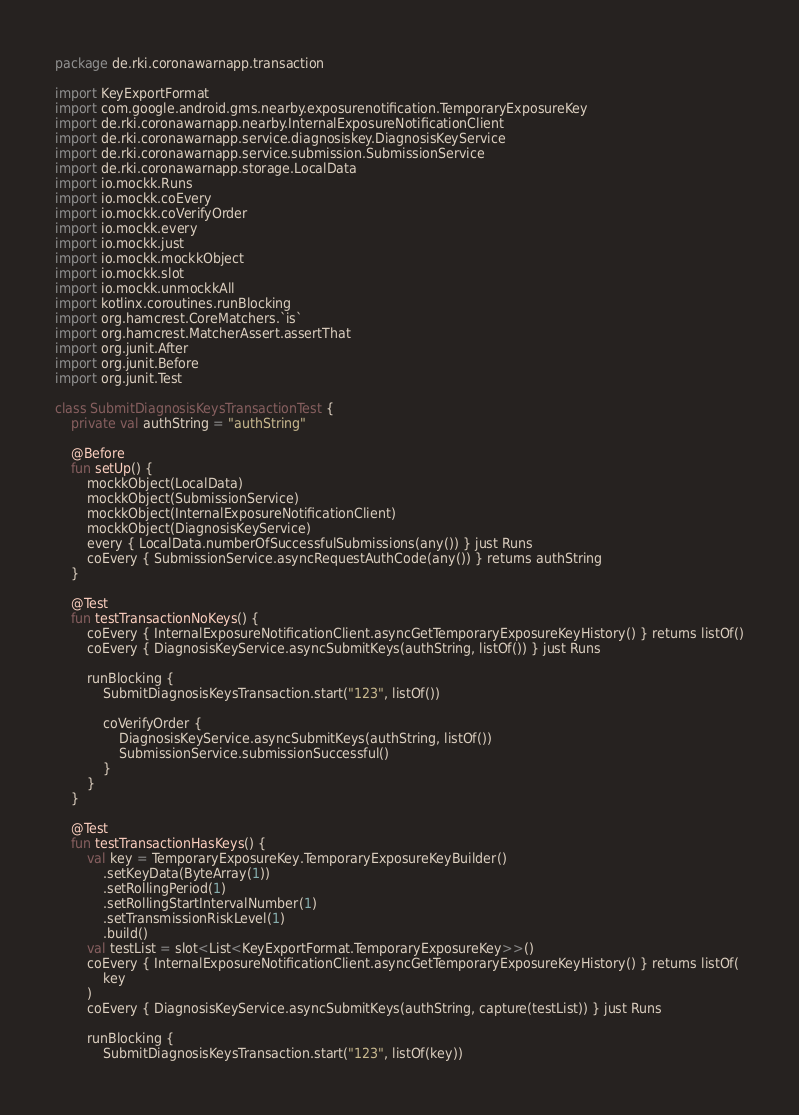Convert code to text. <code><loc_0><loc_0><loc_500><loc_500><_Kotlin_>package de.rki.coronawarnapp.transaction

import KeyExportFormat
import com.google.android.gms.nearby.exposurenotification.TemporaryExposureKey
import de.rki.coronawarnapp.nearby.InternalExposureNotificationClient
import de.rki.coronawarnapp.service.diagnosiskey.DiagnosisKeyService
import de.rki.coronawarnapp.service.submission.SubmissionService
import de.rki.coronawarnapp.storage.LocalData
import io.mockk.Runs
import io.mockk.coEvery
import io.mockk.coVerifyOrder
import io.mockk.every
import io.mockk.just
import io.mockk.mockkObject
import io.mockk.slot
import io.mockk.unmockkAll
import kotlinx.coroutines.runBlocking
import org.hamcrest.CoreMatchers.`is`
import org.hamcrest.MatcherAssert.assertThat
import org.junit.After
import org.junit.Before
import org.junit.Test

class SubmitDiagnosisKeysTransactionTest {
    private val authString = "authString"

    @Before
    fun setUp() {
        mockkObject(LocalData)
        mockkObject(SubmissionService)
        mockkObject(InternalExposureNotificationClient)
        mockkObject(DiagnosisKeyService)
        every { LocalData.numberOfSuccessfulSubmissions(any()) } just Runs
        coEvery { SubmissionService.asyncRequestAuthCode(any()) } returns authString
    }

    @Test
    fun testTransactionNoKeys() {
        coEvery { InternalExposureNotificationClient.asyncGetTemporaryExposureKeyHistory() } returns listOf()
        coEvery { DiagnosisKeyService.asyncSubmitKeys(authString, listOf()) } just Runs

        runBlocking {
            SubmitDiagnosisKeysTransaction.start("123", listOf())

            coVerifyOrder {
                DiagnosisKeyService.asyncSubmitKeys(authString, listOf())
                SubmissionService.submissionSuccessful()
            }
        }
    }

    @Test
    fun testTransactionHasKeys() {
        val key = TemporaryExposureKey.TemporaryExposureKeyBuilder()
            .setKeyData(ByteArray(1))
            .setRollingPeriod(1)
            .setRollingStartIntervalNumber(1)
            .setTransmissionRiskLevel(1)
            .build()
        val testList = slot<List<KeyExportFormat.TemporaryExposureKey>>()
        coEvery { InternalExposureNotificationClient.asyncGetTemporaryExposureKeyHistory() } returns listOf(
            key
        )
        coEvery { DiagnosisKeyService.asyncSubmitKeys(authString, capture(testList)) } just Runs

        runBlocking {
            SubmitDiagnosisKeysTransaction.start("123", listOf(key))
</code> 